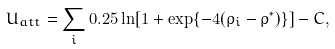Convert formula to latex. <formula><loc_0><loc_0><loc_500><loc_500>U _ { a t t } = \sum _ { i } 0 . 2 5 \ln [ 1 + \exp \{ - 4 ( \rho _ { i } - \rho ^ { * } ) \} ] - C ,</formula> 